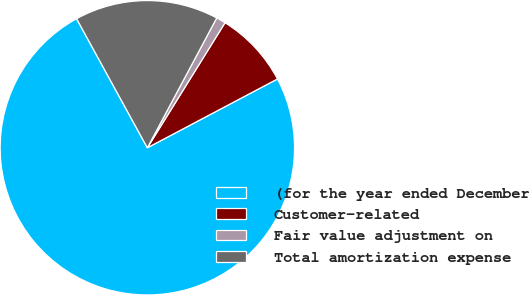<chart> <loc_0><loc_0><loc_500><loc_500><pie_chart><fcel>(for the year ended December<fcel>Customer-related<fcel>Fair value adjustment on<fcel>Total amortization expense<nl><fcel>74.76%<fcel>8.41%<fcel>1.04%<fcel>15.79%<nl></chart> 